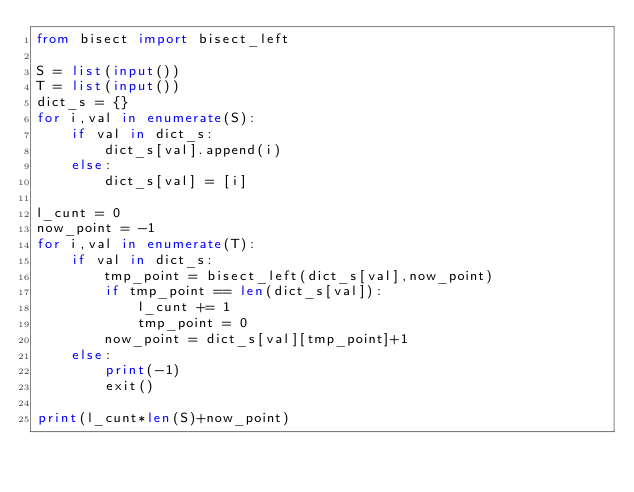<code> <loc_0><loc_0><loc_500><loc_500><_Python_>from bisect import bisect_left

S = list(input())
T = list(input())
dict_s = {}
for i,val in enumerate(S):
    if val in dict_s:
        dict_s[val].append(i)
    else:
        dict_s[val] = [i]

l_cunt = 0
now_point = -1
for i,val in enumerate(T):
    if val in dict_s:
        tmp_point = bisect_left(dict_s[val],now_point)
        if tmp_point == len(dict_s[val]):
            l_cunt += 1
            tmp_point = 0
        now_point = dict_s[val][tmp_point]+1
    else:
        print(-1)
        exit()

print(l_cunt*len(S)+now_point)</code> 